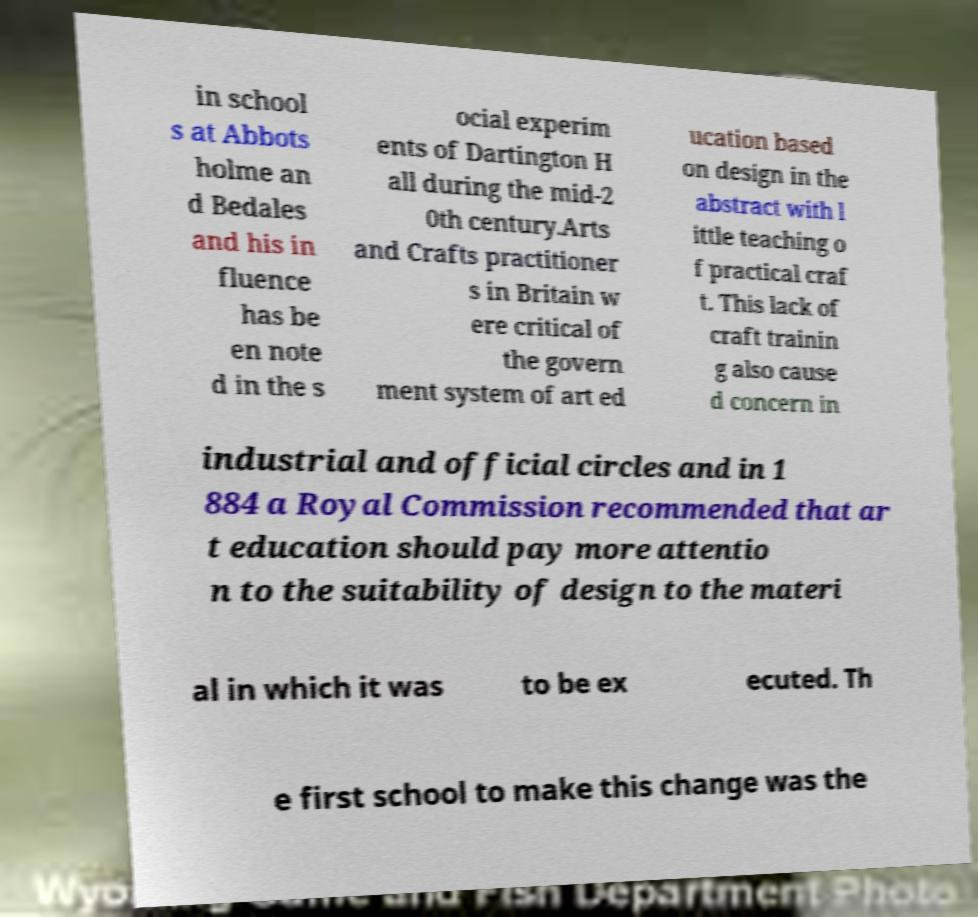Could you extract and type out the text from this image? in school s at Abbots holme an d Bedales and his in fluence has be en note d in the s ocial experim ents of Dartington H all during the mid-2 0th century.Arts and Crafts practitioner s in Britain w ere critical of the govern ment system of art ed ucation based on design in the abstract with l ittle teaching o f practical craf t. This lack of craft trainin g also cause d concern in industrial and official circles and in 1 884 a Royal Commission recommended that ar t education should pay more attentio n to the suitability of design to the materi al in which it was to be ex ecuted. Th e first school to make this change was the 